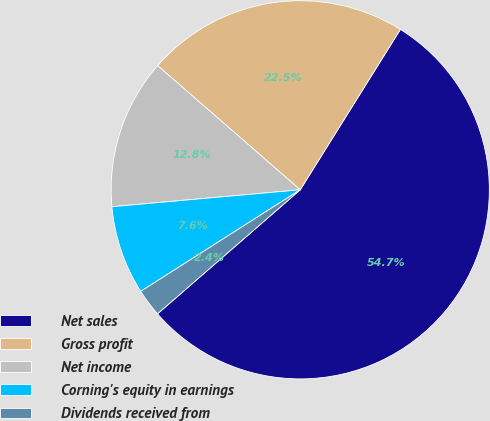<chart> <loc_0><loc_0><loc_500><loc_500><pie_chart><fcel>Net sales<fcel>Gross profit<fcel>Net income<fcel>Corning's equity in earnings<fcel>Dividends received from<nl><fcel>54.73%<fcel>22.48%<fcel>12.83%<fcel>7.6%<fcel>2.36%<nl></chart> 